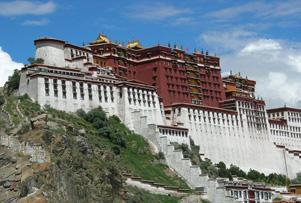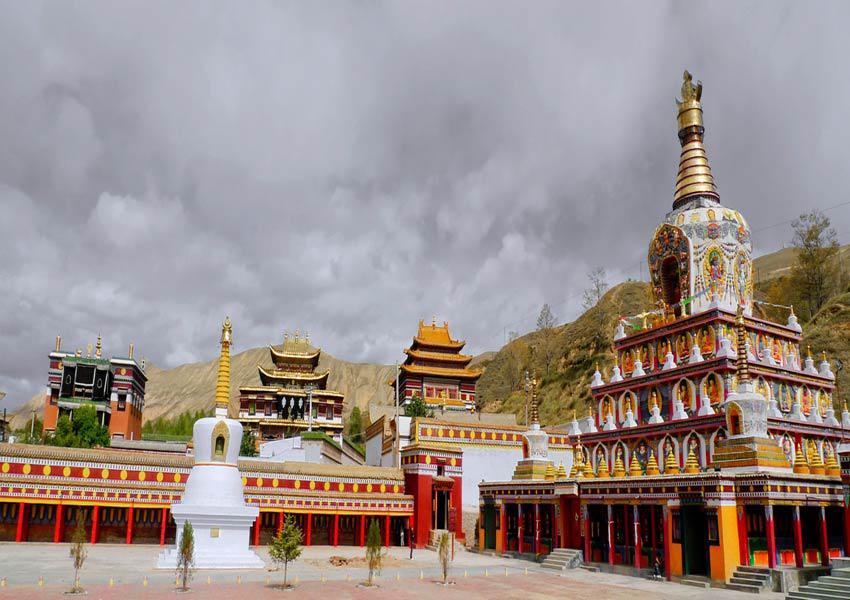The first image is the image on the left, the second image is the image on the right. Examine the images to the left and right. Is the description "Left image includes a steep foliage-covered slope and a blue cloud-scattered sky in the scene with a building led to by a stairway." accurate? Answer yes or no. Yes. The first image is the image on the left, the second image is the image on the right. For the images displayed, is the sentence "There is an empty parking lot in front of a building in at least one of the images." factually correct? Answer yes or no. No. 